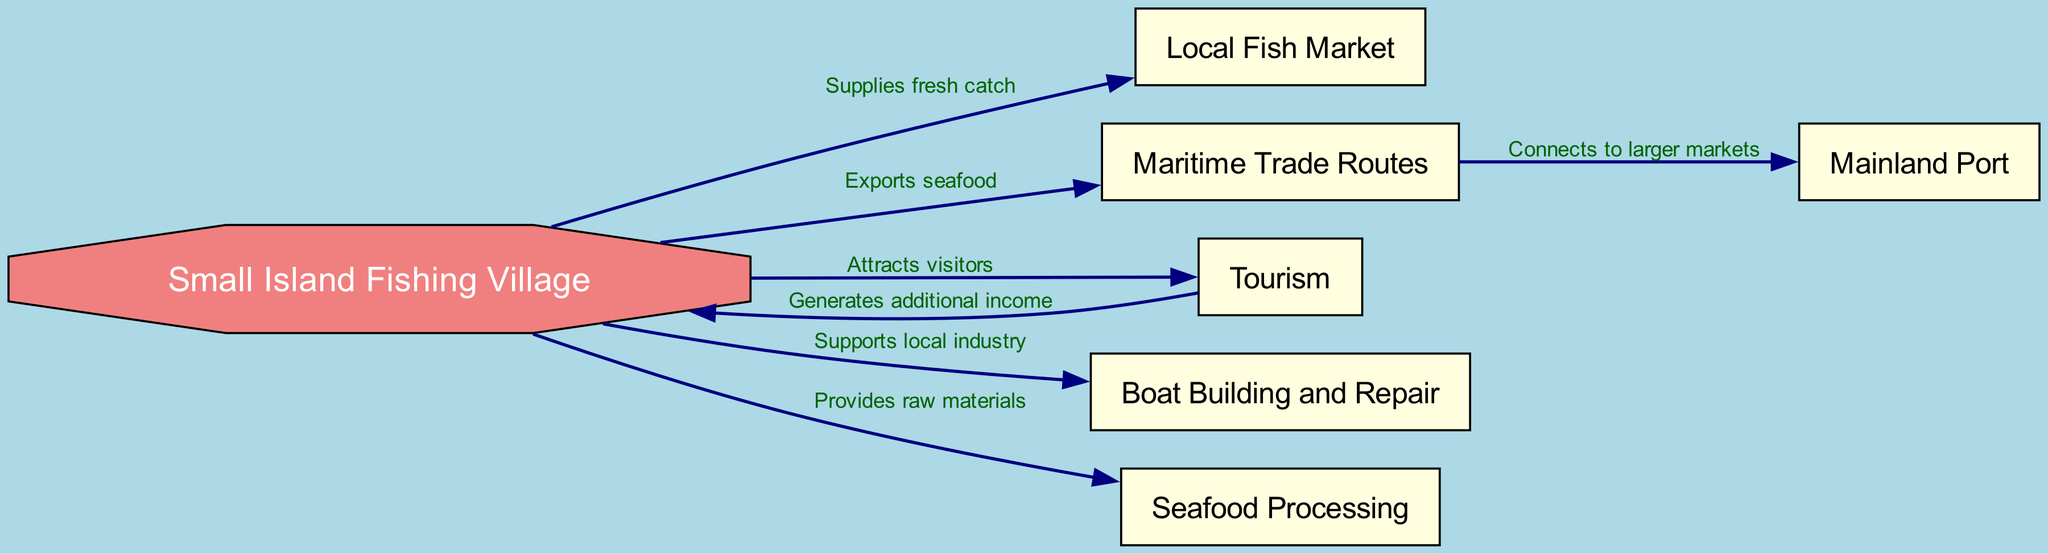What is the central node in the diagram? The central node representing the main concept of the diagram is "Small Island Fishing Village." This is inferred as it has multiple connections leading out to other nodes, indicating it is the main subject of the economic structure portrayed.
Answer: Small Island Fishing Village How many nodes are there in the diagram? By counting all the unique entities represented as nodes in the diagram, we find there are a total of six nodes.
Answer: 6 What connects the fishing village to the local fish market? The edge labeled "Supplies fresh catch" shows the direct relationship where the fishing village provides fresh fish to the local market. This connection describes a clear economic interaction between the village and the market.
Answer: Supplies fresh catch What role does tourism play in the fishing village's economy? The diagram indicates that tourism "Generates additional income" for the fishing village. This means that the influx of visitors contributes financially to the village, enhancing its economic structure.
Answer: Generates additional income Which node is directly tied to mainland trade? The "Mainland Port" node is connected to "Maritime Trade Routes" through an edge labeled "Connects to larger markets." This demonstrates the importance of the port for accessing broader trading opportunities beyond the village.
Answer: Mainland Port What industry is supported by the fishing village apart from fishing? The "Boat Building and Repair" node indicates a secondary industry that the fishing village supports, which signifies a diversification of economic activities beyond just fishing.
Answer: Boat Building and Repair How many connections does the fishing village have? The fishing village has five outgoing edges connecting it to other nodes: fish market, trade routes, tourism, boat building, and seafood processing. This highlights its central role in several economic activities.
Answer: 5 What does seafood processing provide to the fishing village? According to the diagram, seafood processing "Provides raw materials" to support the fishing village's economy. This indicates a relationship where the fishing activities contribute materials that are further processed.
Answer: Provides raw materials 